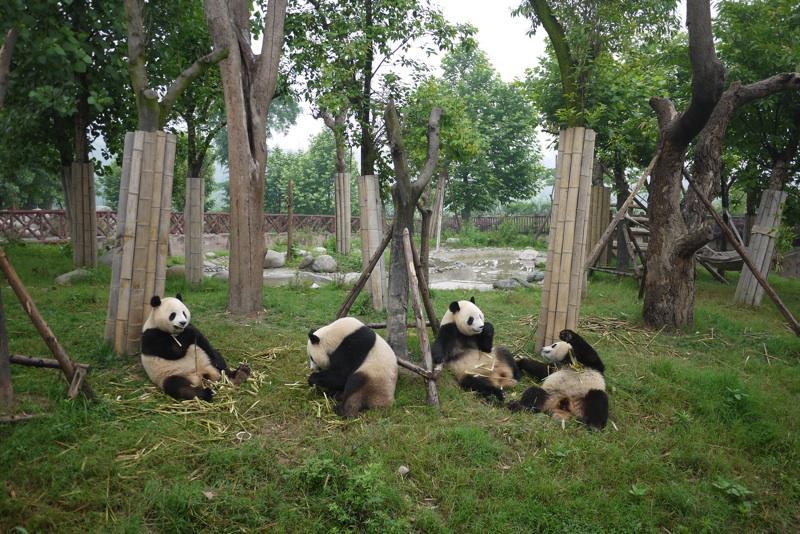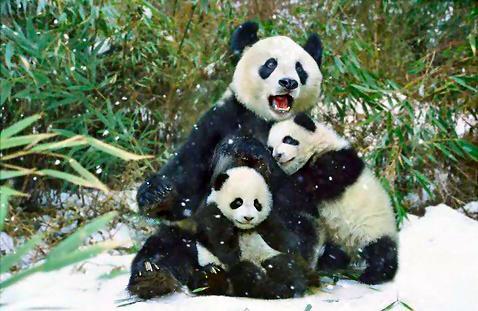The first image is the image on the left, the second image is the image on the right. Examine the images to the left and right. Is the description "There is a single panda in one of the images." accurate? Answer yes or no. No. The first image is the image on the left, the second image is the image on the right. Considering the images on both sides, is "There are at most three pandas in one of the images." valid? Answer yes or no. Yes. 